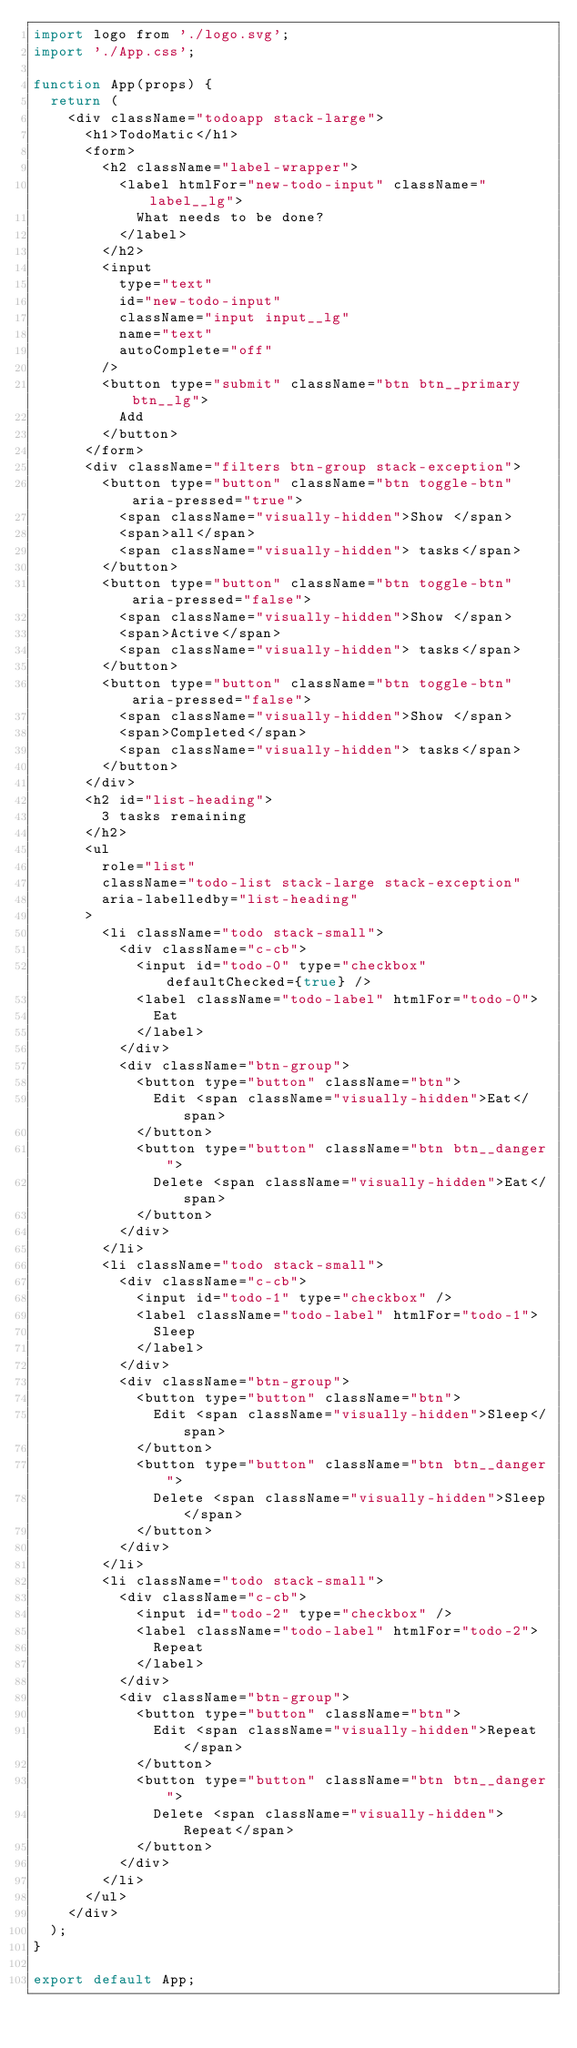Convert code to text. <code><loc_0><loc_0><loc_500><loc_500><_JavaScript_>import logo from './logo.svg';
import './App.css';

function App(props) {
  return (
    <div className="todoapp stack-large">
      <h1>TodoMatic</h1>
      <form>
        <h2 className="label-wrapper">
          <label htmlFor="new-todo-input" className="label__lg">
            What needs to be done?
          </label>
        </h2>
        <input
          type="text"
          id="new-todo-input"
          className="input input__lg"
          name="text"
          autoComplete="off"
        />
        <button type="submit" className="btn btn__primary btn__lg">
          Add
        </button>
      </form>
      <div className="filters btn-group stack-exception">
        <button type="button" className="btn toggle-btn" aria-pressed="true">
          <span className="visually-hidden">Show </span>
          <span>all</span>
          <span className="visually-hidden"> tasks</span>
        </button>
        <button type="button" className="btn toggle-btn" aria-pressed="false">
          <span className="visually-hidden">Show </span>
          <span>Active</span>
          <span className="visually-hidden"> tasks</span>
        </button>
        <button type="button" className="btn toggle-btn" aria-pressed="false">
          <span className="visually-hidden">Show </span>
          <span>Completed</span>
          <span className="visually-hidden"> tasks</span>
        </button>
      </div>
      <h2 id="list-heading">
        3 tasks remaining
      </h2>
      <ul
        role="list"
        className="todo-list stack-large stack-exception"
        aria-labelledby="list-heading"
      >
        <li className="todo stack-small">
          <div className="c-cb">
            <input id="todo-0" type="checkbox" defaultChecked={true} />
            <label className="todo-label" htmlFor="todo-0">
              Eat
            </label>
          </div>
          <div className="btn-group">
            <button type="button" className="btn">
              Edit <span className="visually-hidden">Eat</span>
            </button>
            <button type="button" className="btn btn__danger">
              Delete <span className="visually-hidden">Eat</span>
            </button>
          </div>
        </li>
        <li className="todo stack-small">
          <div className="c-cb">
            <input id="todo-1" type="checkbox" />
            <label className="todo-label" htmlFor="todo-1">
              Sleep
            </label>
          </div>
          <div className="btn-group">
            <button type="button" className="btn">
              Edit <span className="visually-hidden">Sleep</span>
            </button>
            <button type="button" className="btn btn__danger">
              Delete <span className="visually-hidden">Sleep</span>
            </button>
          </div>
        </li>
        <li className="todo stack-small">
          <div className="c-cb">
            <input id="todo-2" type="checkbox" />
            <label className="todo-label" htmlFor="todo-2">
              Repeat
            </label>
          </div>
          <div className="btn-group">
            <button type="button" className="btn">
              Edit <span className="visually-hidden">Repeat</span>
            </button>
            <button type="button" className="btn btn__danger">
              Delete <span className="visually-hidden">Repeat</span>
            </button>
          </div>
        </li>
      </ul>
    </div>
  );
}

export default App;
</code> 